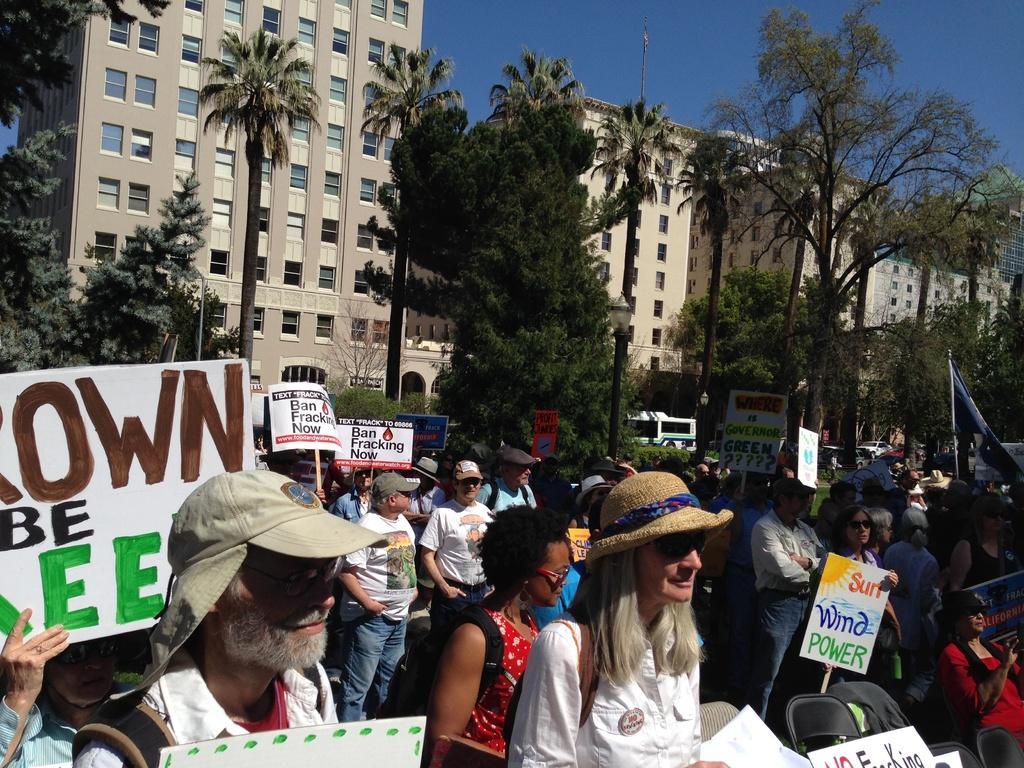Could you give a brief overview of what you see in this image? In the center of the image we can see a few people are standing. Among them, we can see a few people are holding banners, few people are wearing caps, one person is sitting on the chair and few people are wearing glasses. And we can see chairs and a few other objects. On the banners, we can see some text. In the background we can see the sky, buildings, windows, trees, vehicles, one flag and a few other objects. 